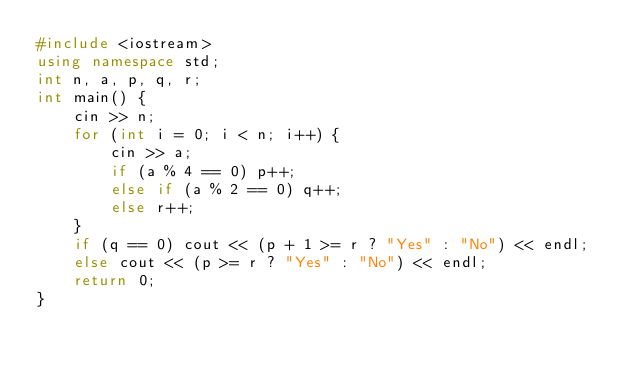Convert code to text. <code><loc_0><loc_0><loc_500><loc_500><_C++_>#include <iostream>
using namespace std;
int n, a, p, q, r;
int main() {
	cin >> n;
	for (int i = 0; i < n; i++) {
		cin >> a;
		if (a % 4 == 0) p++;
		else if (a % 2 == 0) q++;
		else r++;
	}
	if (q == 0) cout << (p + 1 >= r ? "Yes" : "No") << endl;
	else cout << (p >= r ? "Yes" : "No") << endl;
	return 0;
}</code> 